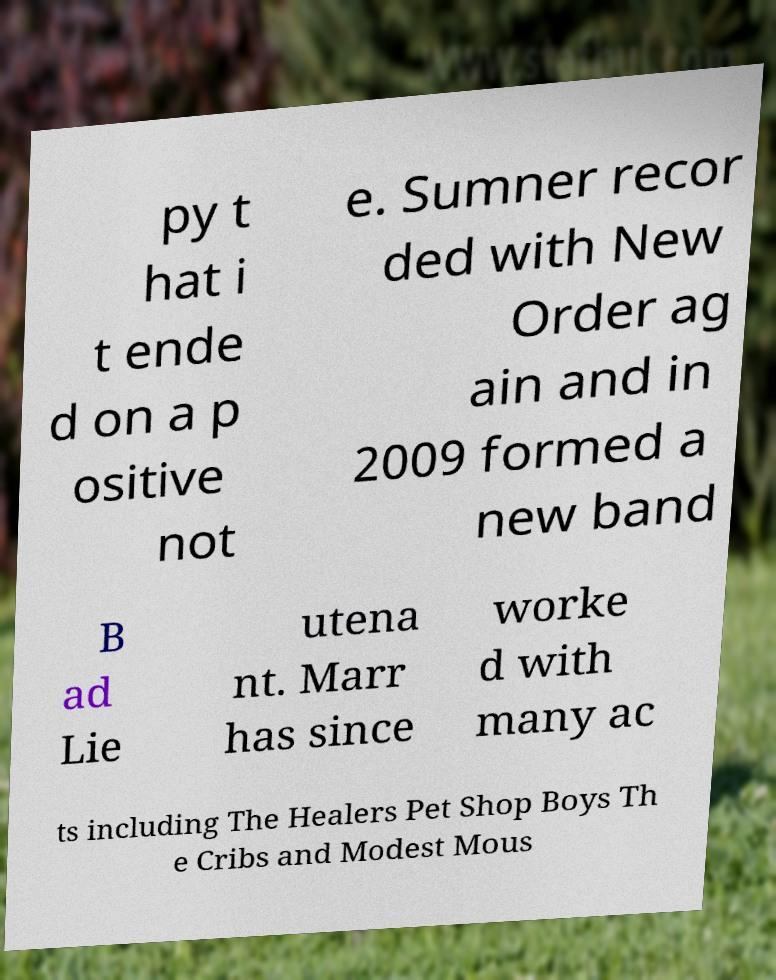There's text embedded in this image that I need extracted. Can you transcribe it verbatim? py t hat i t ende d on a p ositive not e. Sumner recor ded with New Order ag ain and in 2009 formed a new band B ad Lie utena nt. Marr has since worke d with many ac ts including The Healers Pet Shop Boys Th e Cribs and Modest Mous 